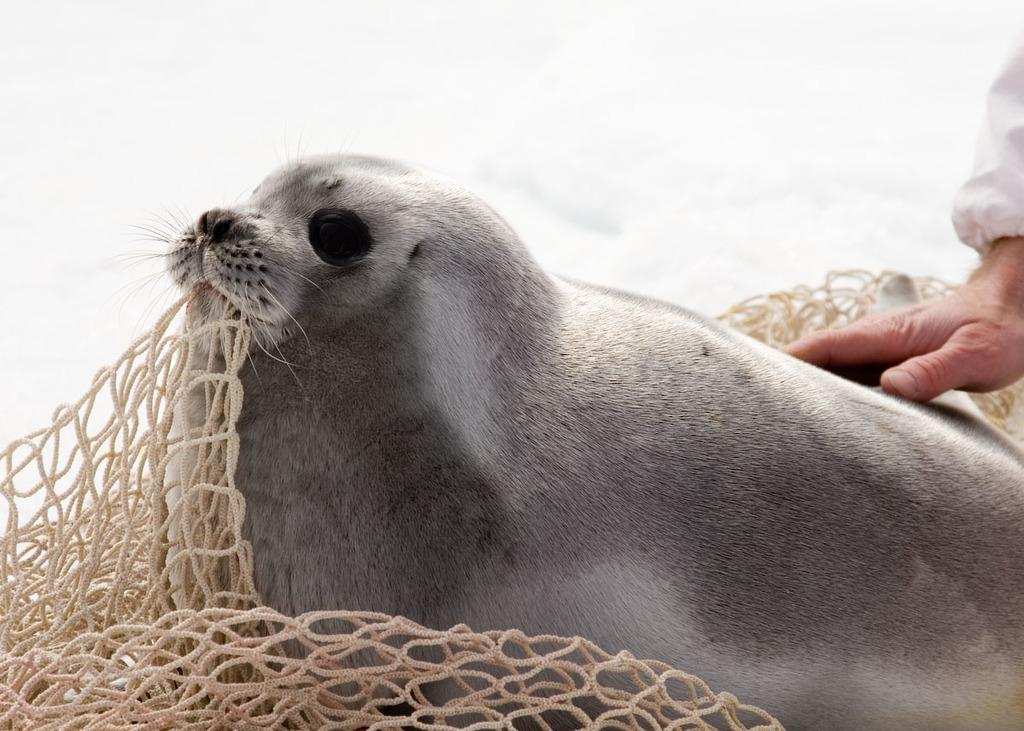What is located in the middle of the image? There is a net in the middle of the image. What type of creature is present in the image? There is an animal in the image. How is the animal interacting with the net? The animal is holding the net with its mouth. Can you describe any human involvement in the image? There is a person's hand visible on the right side of the image. How many beds are visible in the image? There are no beds present in the image. What type of giant can be seen interacting with the animal in the image? There is no giant present in the image; the animal is holding the net with its mouth. Can you describe the goat in the image? There is no goat present in the image. 